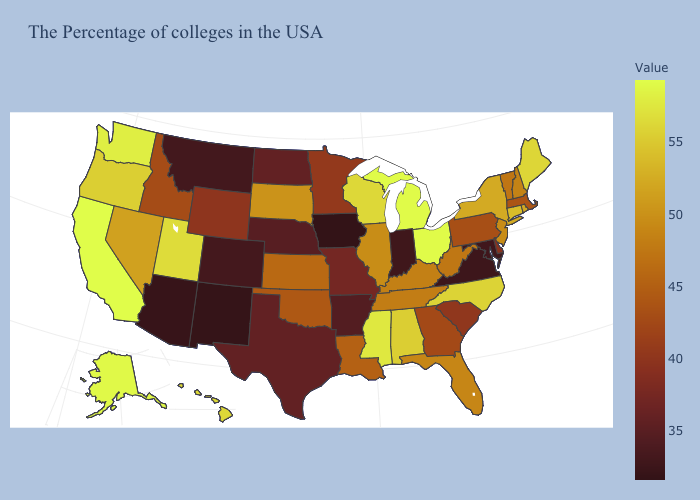Which states hav the highest value in the Northeast?
Concise answer only. Maine. Which states have the lowest value in the South?
Write a very short answer. Virginia. Does Vermont have a lower value than Maine?
Be succinct. Yes. Does the map have missing data?
Short answer required. No. Does Massachusetts have a higher value than New Hampshire?
Write a very short answer. No. Is the legend a continuous bar?
Short answer required. Yes. 